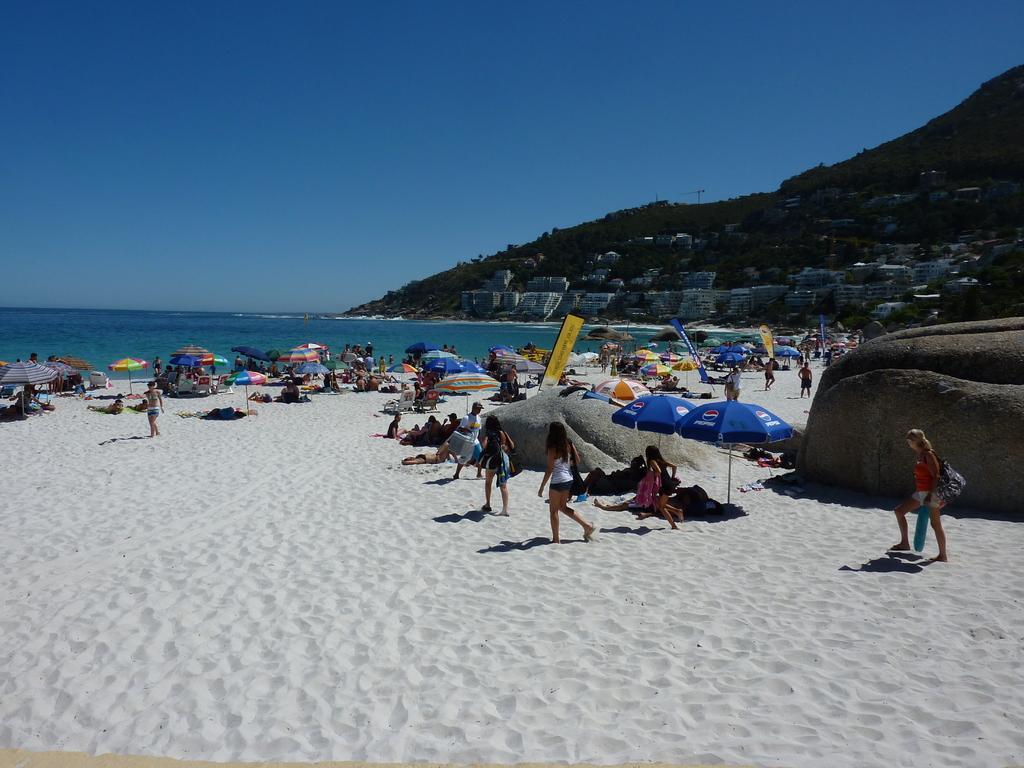Please provide a concise description of this image. In the image there are many people walking and laying under umbrellas on a beach, in the back its ocean on the right side and hill on the left side with trees on it and above its sky. 